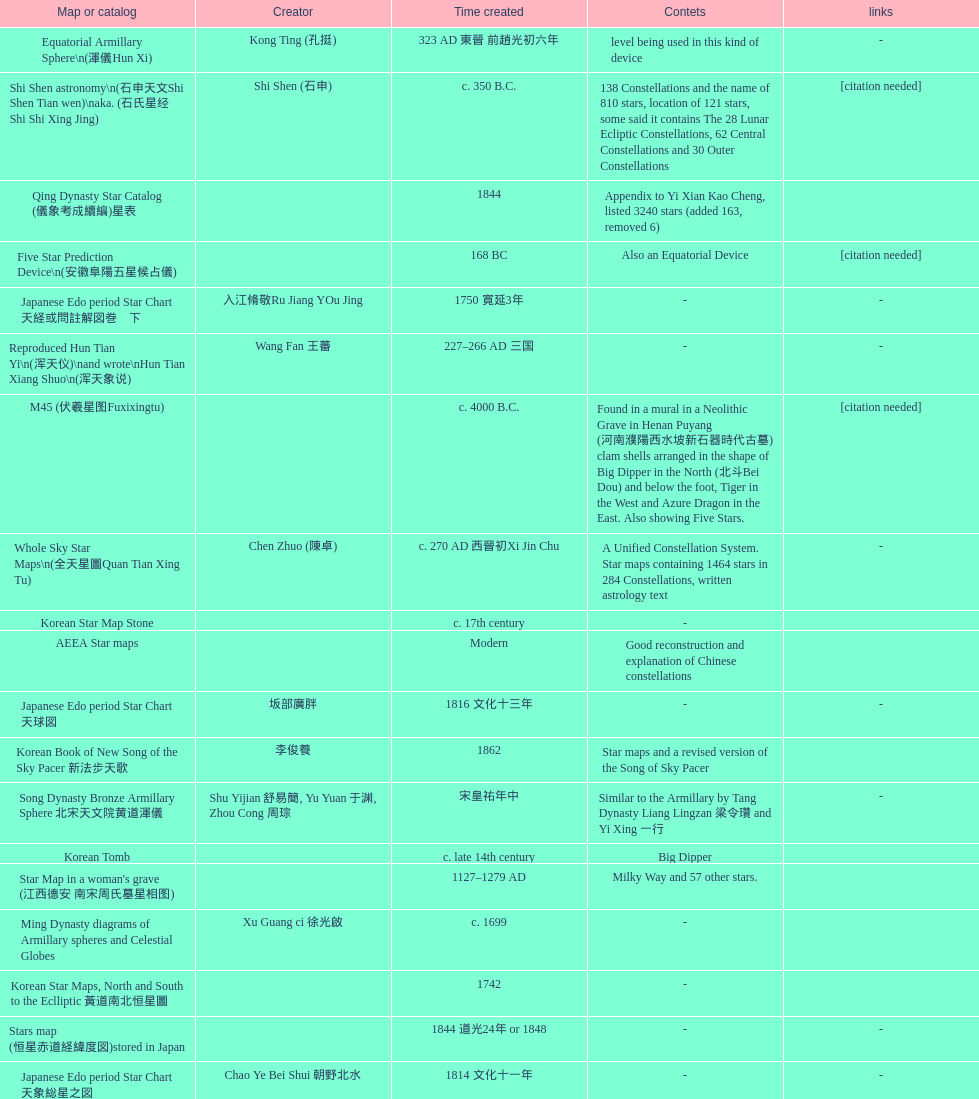Which star map was created earlier, celestial globe or the han grave mural star chart? Celestial Globe. 